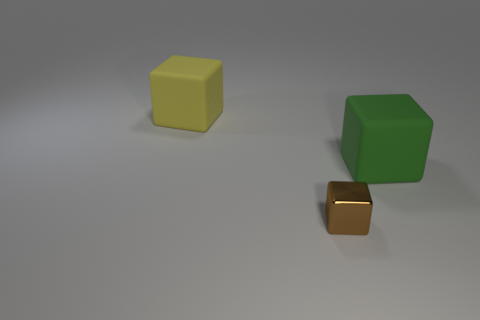Add 3 gray metal objects. How many objects exist? 6 Subtract 0 green balls. How many objects are left? 3 Subtract all small blocks. Subtract all big yellow cubes. How many objects are left? 1 Add 3 green things. How many green things are left? 4 Add 3 large objects. How many large objects exist? 5 